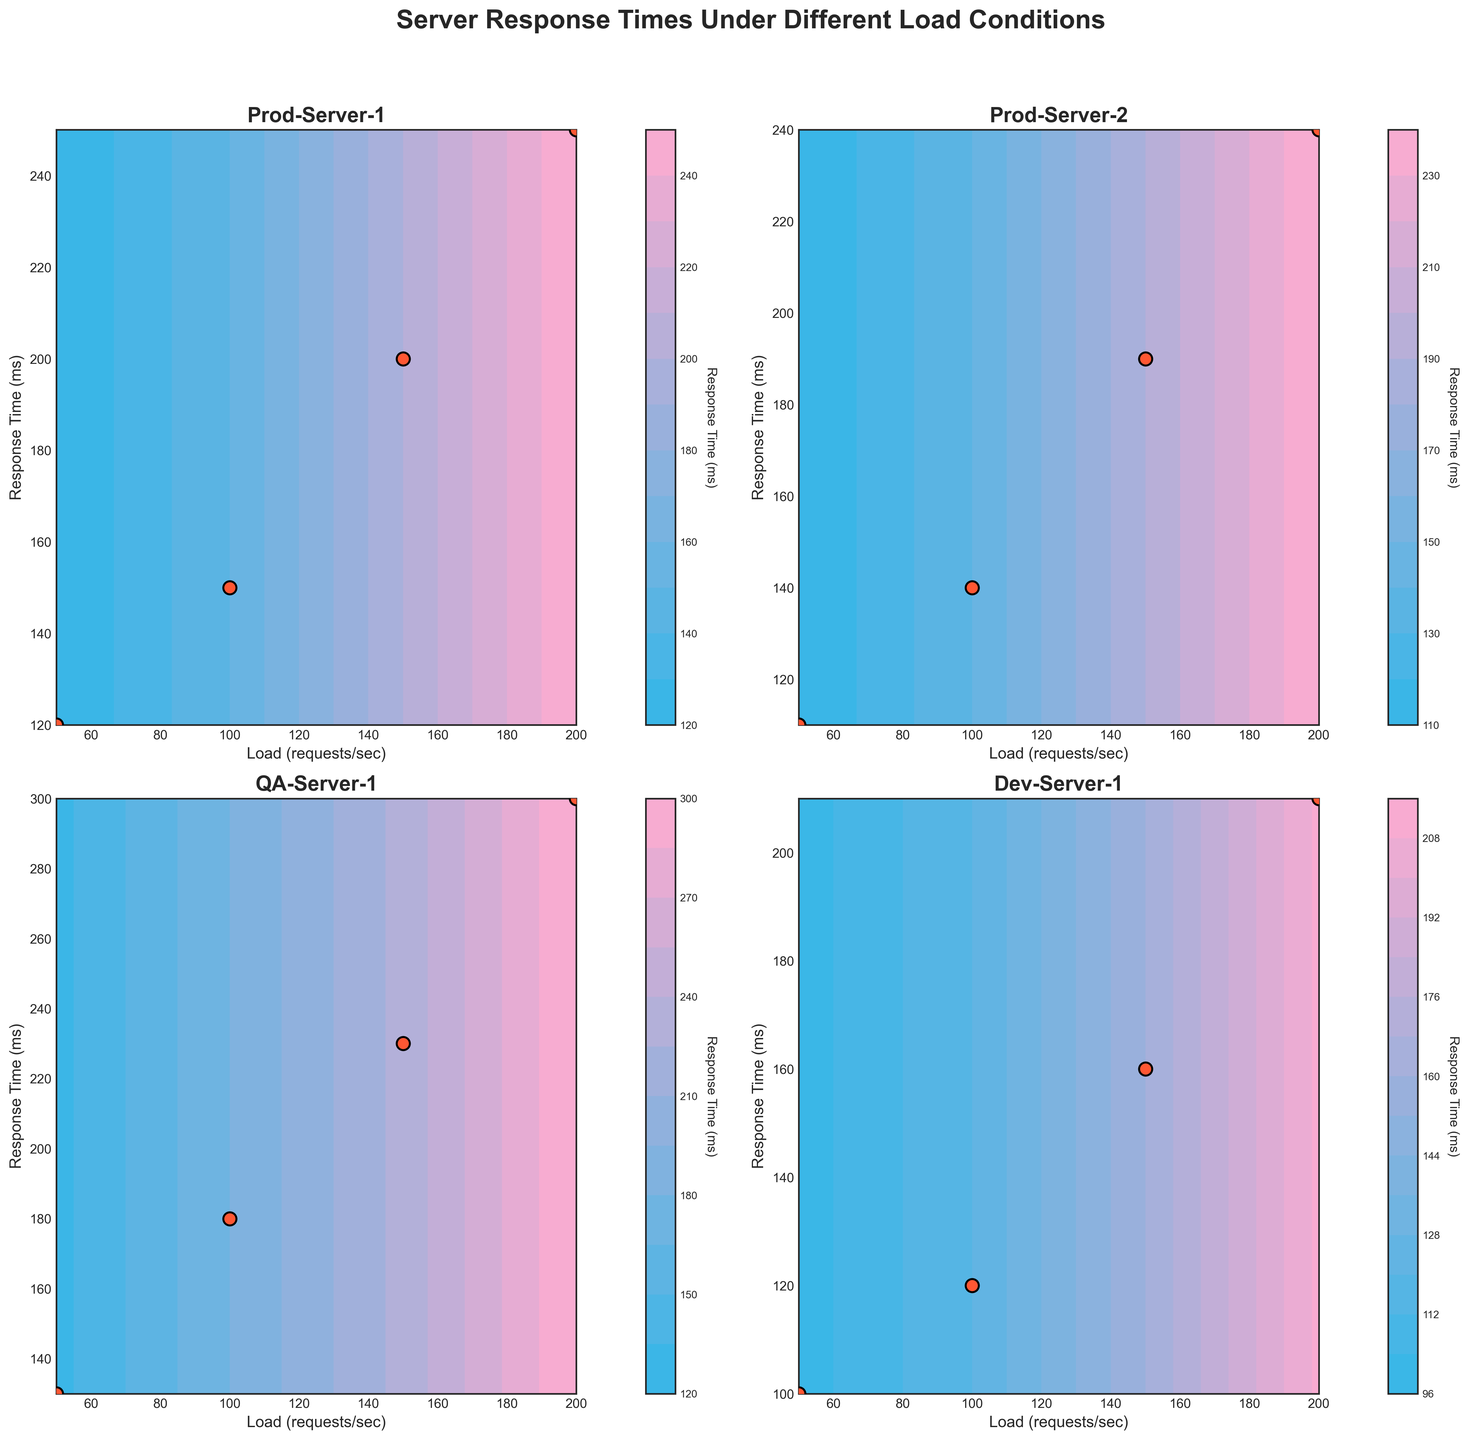What is the title of the figure? The title is displayed at the top center of the figure. It reads "Server Response Times Under Different Load Conditions"
Answer: Server Response Times Under Different Load Conditions How many servers are shown in the subplots? By counting the titles of each subplot, there are four subplots, each representing a different server.
Answer: Four Which server has the highest response time at 100 requests/sec? By looking at the response times at 100 requests/sec for each server, the QA-Server-1 has the highest response time of 180 ms.
Answer: QA-Server-1 What is the range of load conditions presented in each subplot? Observing the x-axis, the load conditions range from 50 to 200 requests per second for all servers.
Answer: 50 to 200 requests per second Compare the response time trends for Prod-Server-1 and Dev-Server-1. Which server handles the load increase better in terms of response times? By observing the gradient of the contours in both subplots, it is apparent that Dev-Server-1 shows a more gradual increase in response time as load increases, whereas Prod-Server-1 shows a steeper increase. Therefore, Dev-Server-1 handles load increase better.
Answer: Dev-Server-1 Which server shows the most significant increase in response time from 50 to 200 requests/sec? By examining the distances and color shifts between the response times at 50 and 200 requests/sec, QA-Server-1 shows the most significant increase, from 130 ms to 300 ms.
Answer: QA-Server-1 What color is used to represent lower response times in the contour plots? The color representing lower response times is a shade of blue, as indicated by the custom colormap used in the figure.
Answer: Blue Can you observe any outliers or unusual patterns in the subplots? There are no visible outliers; the data points follow a consistent trend in increasing response time with increasing load.
Answer: No Which server has the lowest response time at 50 requests/sec? By looking at the response times at 50 requests/sec for each server, Dev-Server-1 has the lowest response time of 100 ms.
Answer: Dev-Server-1 How does the response time at 150 requests/sec compare between Prod-Server-2 and QA-Server-1? Prod-Server-2 has a response time of 190 ms at 150 requests/sec, while QA-Server-1 has a response time of 230 ms. Therefore, Prod-Server-2 has a lower response time at this load.
Answer: Prod-Server-2 